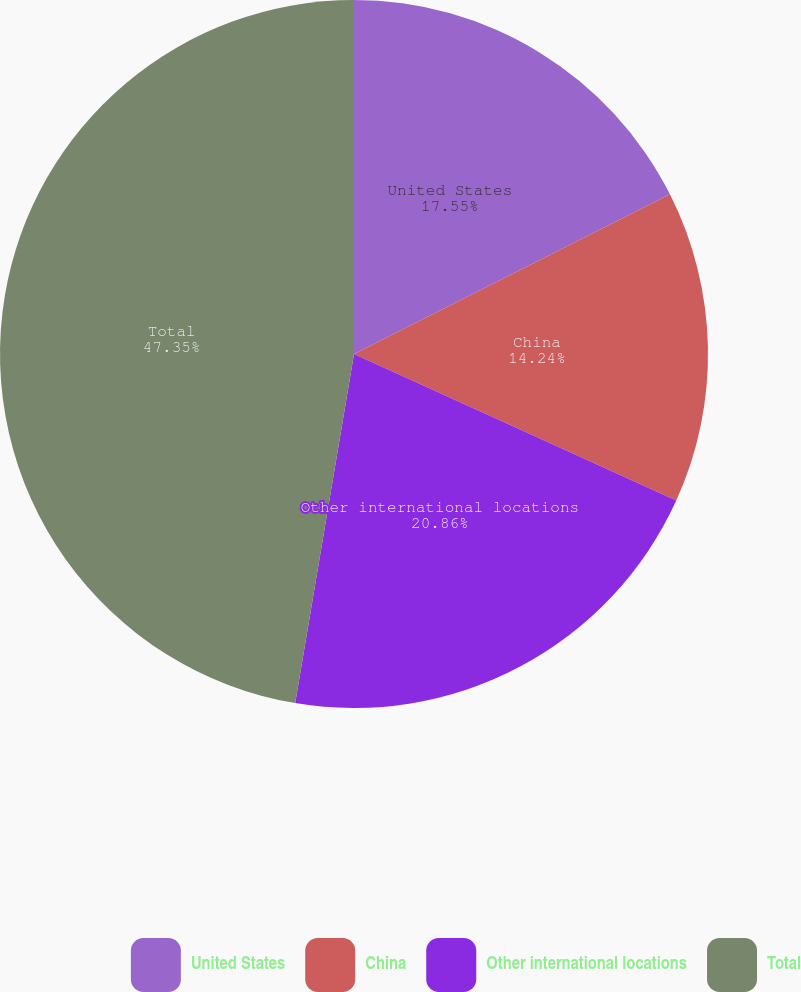Convert chart. <chart><loc_0><loc_0><loc_500><loc_500><pie_chart><fcel>United States<fcel>China<fcel>Other international locations<fcel>Total<nl><fcel>17.55%<fcel>14.24%<fcel>20.86%<fcel>47.34%<nl></chart> 